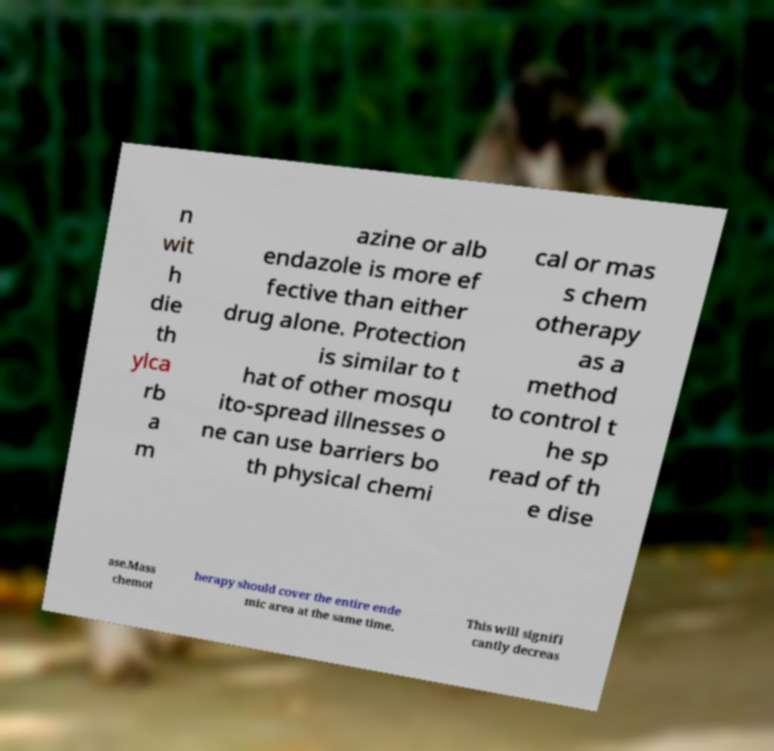Could you assist in decoding the text presented in this image and type it out clearly? n wit h die th ylca rb a m azine or alb endazole is more ef fective than either drug alone. Protection is similar to t hat of other mosqu ito-spread illnesses o ne can use barriers bo th physical chemi cal or mas s chem otherapy as a method to control t he sp read of th e dise ase.Mass chemot herapy should cover the entire ende mic area at the same time. This will signifi cantly decreas 